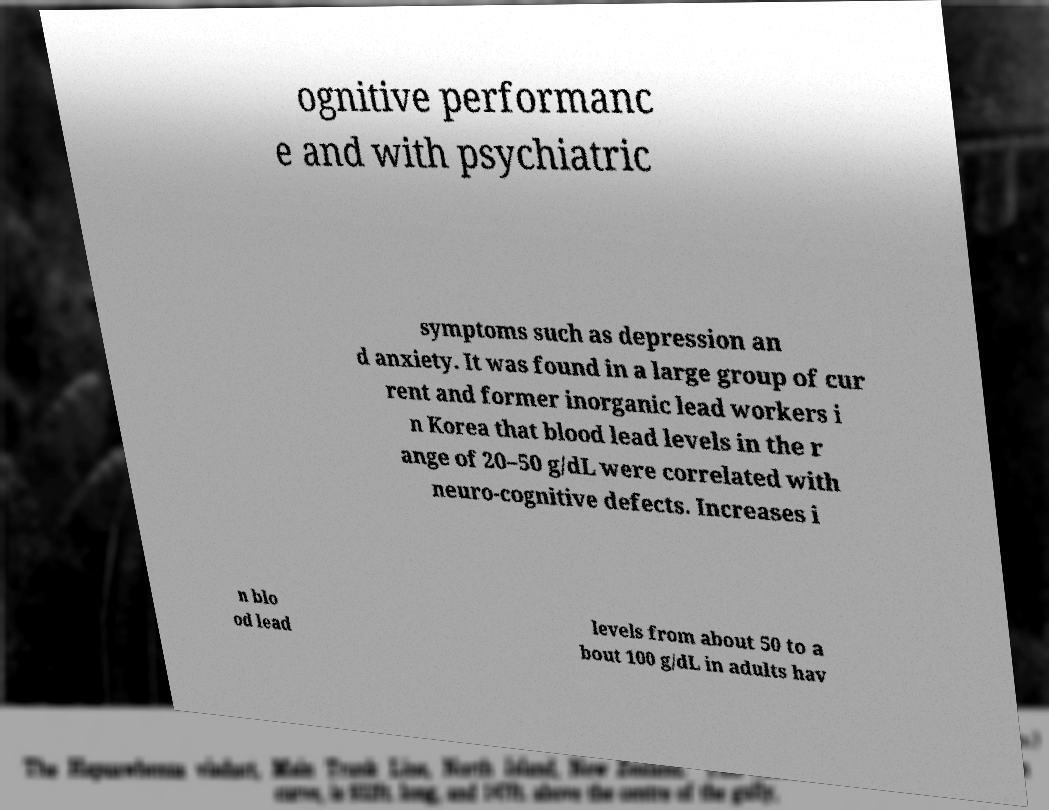Could you assist in decoding the text presented in this image and type it out clearly? ognitive performanc e and with psychiatric symptoms such as depression an d anxiety. It was found in a large group of cur rent and former inorganic lead workers i n Korea that blood lead levels in the r ange of 20–50 g/dL were correlated with neuro-cognitive defects. Increases i n blo od lead levels from about 50 to a bout 100 g/dL in adults hav 